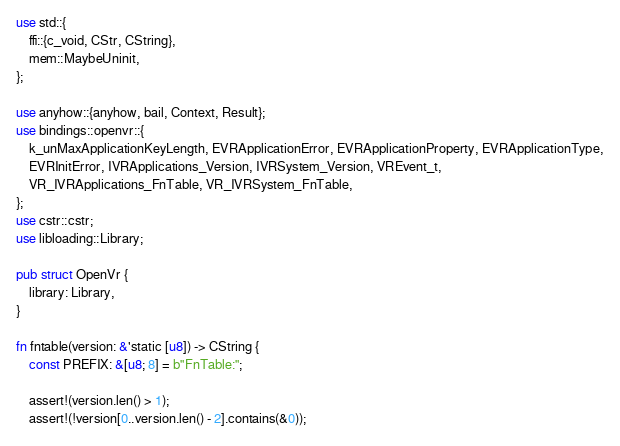<code> <loc_0><loc_0><loc_500><loc_500><_Rust_>use std::{
    ffi::{c_void, CStr, CString},
    mem::MaybeUninit,
};

use anyhow::{anyhow, bail, Context, Result};
use bindings::openvr::{
    k_unMaxApplicationKeyLength, EVRApplicationError, EVRApplicationProperty, EVRApplicationType,
    EVRInitError, IVRApplications_Version, IVRSystem_Version, VREvent_t,
    VR_IVRApplications_FnTable, VR_IVRSystem_FnTable,
};
use cstr::cstr;
use libloading::Library;

pub struct OpenVr {
    library: Library,
}

fn fntable(version: &'static [u8]) -> CString {
    const PREFIX: &[u8; 8] = b"FnTable:";

    assert!(version.len() > 1);
    assert!(!version[0..version.len() - 2].contains(&0));</code> 